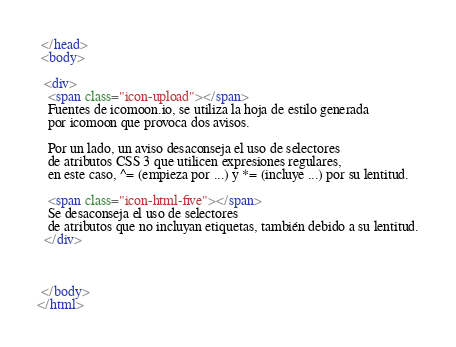<code> <loc_0><loc_0><loc_500><loc_500><_HTML_> </head>
 <body>

  <div>
   <span class="icon-upload"></span>
   Fuentes de icomoon.io, se utiliza la hoja de estilo generada 
   por icomoon que provoca dos avisos.

   Por un lado, un aviso desaconseja el uso de selectores 
   de atributos CSS 3 que utilicen expresiones regulares, 
   en este caso, ^= (empieza por ...) y *= (incluye ...) por su lentitud. 

   <span class="icon-html-five"></span>
   Se desaconseja el uso de selectores 
   de atributos que no incluyan etiquetas, también debido a su lentitud.
  </div>



 </body>
</html>
</code> 